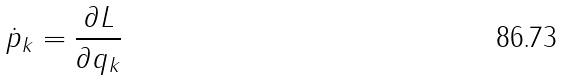Convert formula to latex. <formula><loc_0><loc_0><loc_500><loc_500>\dot { p } _ { k } = \frac { \partial L } { \partial q _ { k } }</formula> 